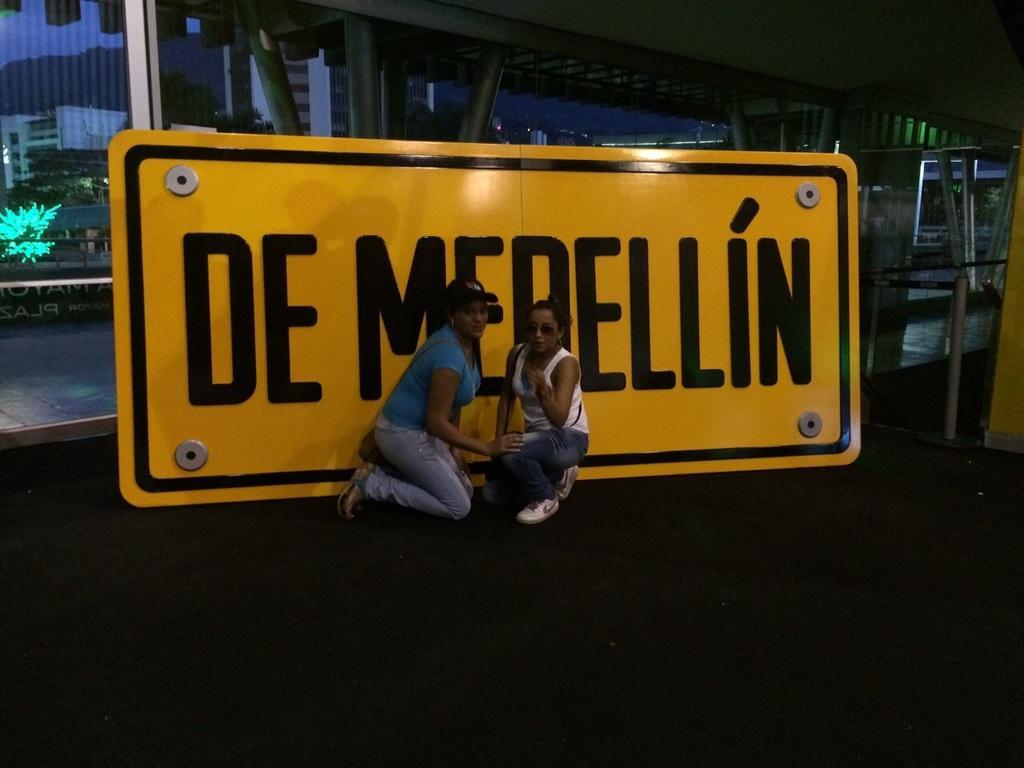Describe this image in one or two sentences. In this image in the center there are two persons who are sitting on their knees, and in the background there is a board. On the board there is some text and in the background there are some poles glass windows, houses and mountains. On the right side there are some poles, at the bottom there is a floor. 